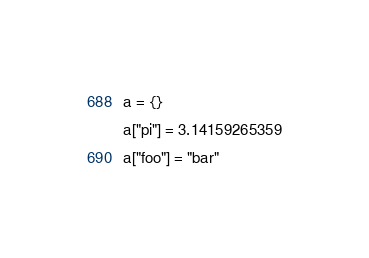<code> <loc_0><loc_0><loc_500><loc_500><_Lua_>a = {}
a["pi"] = 3.14159265359
a["foo"] = "bar"
</code> 